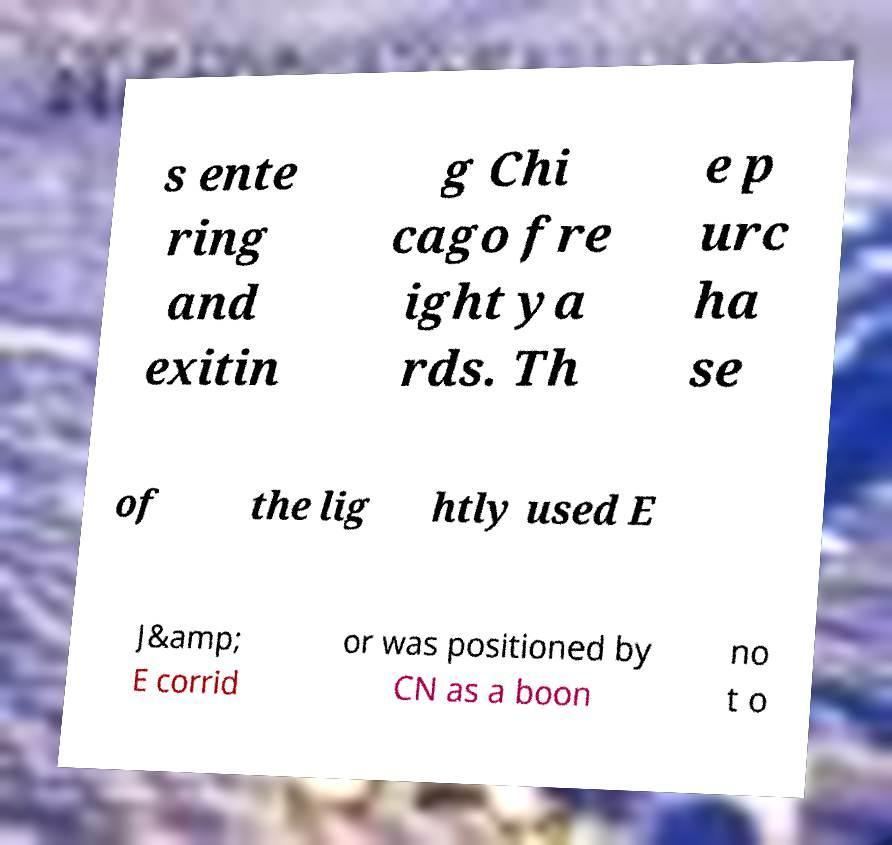There's text embedded in this image that I need extracted. Can you transcribe it verbatim? s ente ring and exitin g Chi cago fre ight ya rds. Th e p urc ha se of the lig htly used E J&amp; E corrid or was positioned by CN as a boon no t o 